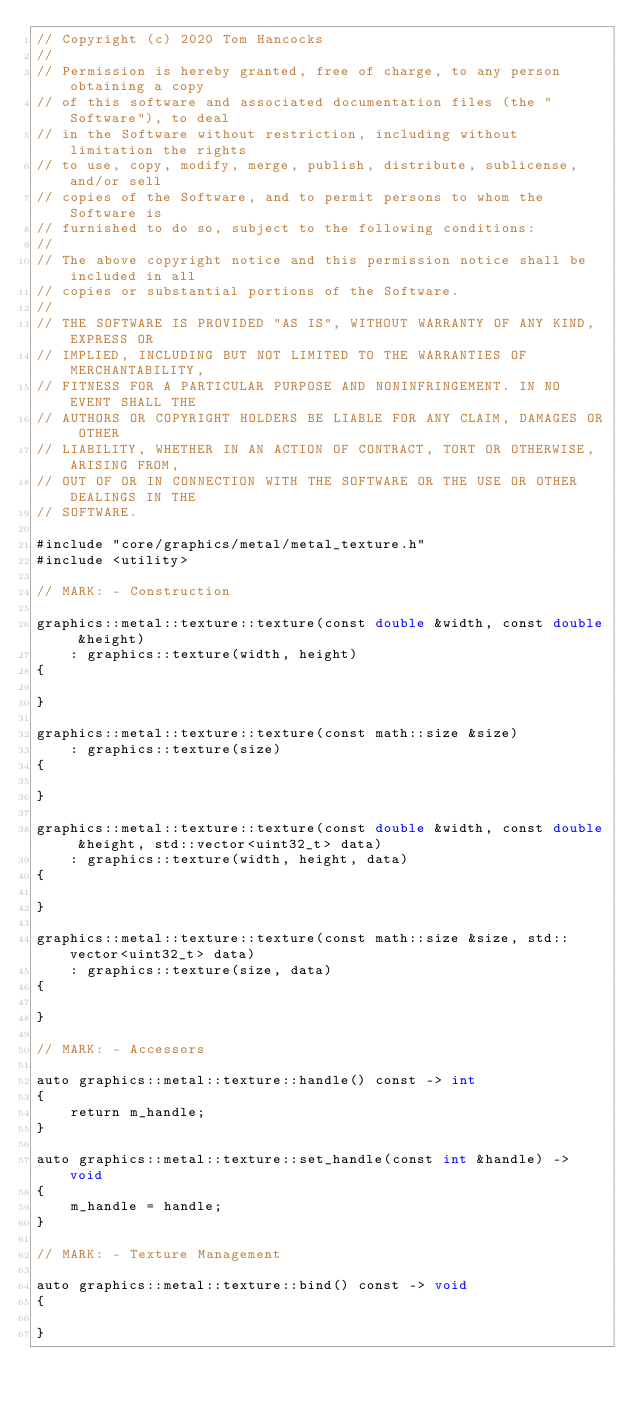Convert code to text. <code><loc_0><loc_0><loc_500><loc_500><_ObjectiveC_>// Copyright (c) 2020 Tom Hancocks
//
// Permission is hereby granted, free of charge, to any person obtaining a copy
// of this software and associated documentation files (the "Software"), to deal
// in the Software without restriction, including without limitation the rights
// to use, copy, modify, merge, publish, distribute, sublicense, and/or sell
// copies of the Software, and to permit persons to whom the Software is
// furnished to do so, subject to the following conditions:
//
// The above copyright notice and this permission notice shall be included in all
// copies or substantial portions of the Software.
//
// THE SOFTWARE IS PROVIDED "AS IS", WITHOUT WARRANTY OF ANY KIND, EXPRESS OR
// IMPLIED, INCLUDING BUT NOT LIMITED TO THE WARRANTIES OF MERCHANTABILITY,
// FITNESS FOR A PARTICULAR PURPOSE AND NONINFRINGEMENT. IN NO EVENT SHALL THE
// AUTHORS OR COPYRIGHT HOLDERS BE LIABLE FOR ANY CLAIM, DAMAGES OR OTHER
// LIABILITY, WHETHER IN AN ACTION OF CONTRACT, TORT OR OTHERWISE, ARISING FROM,
// OUT OF OR IN CONNECTION WITH THE SOFTWARE OR THE USE OR OTHER DEALINGS IN THE
// SOFTWARE.

#include "core/graphics/metal/metal_texture.h"
#include <utility>

// MARK: - Construction

graphics::metal::texture::texture(const double &width, const double &height)
    : graphics::texture(width, height)
{

}

graphics::metal::texture::texture(const math::size &size)
    : graphics::texture(size)
{

}

graphics::metal::texture::texture(const double &width, const double &height, std::vector<uint32_t> data)
    : graphics::texture(width, height, data)
{

}

graphics::metal::texture::texture(const math::size &size, std::vector<uint32_t> data)
    : graphics::texture(size, data)
{

}

// MARK: - Accessors

auto graphics::metal::texture::handle() const -> int
{
    return m_handle;
}

auto graphics::metal::texture::set_handle(const int &handle) -> void
{
    m_handle = handle;
}

// MARK: - Texture Management

auto graphics::metal::texture::bind() const -> void
{

}

</code> 